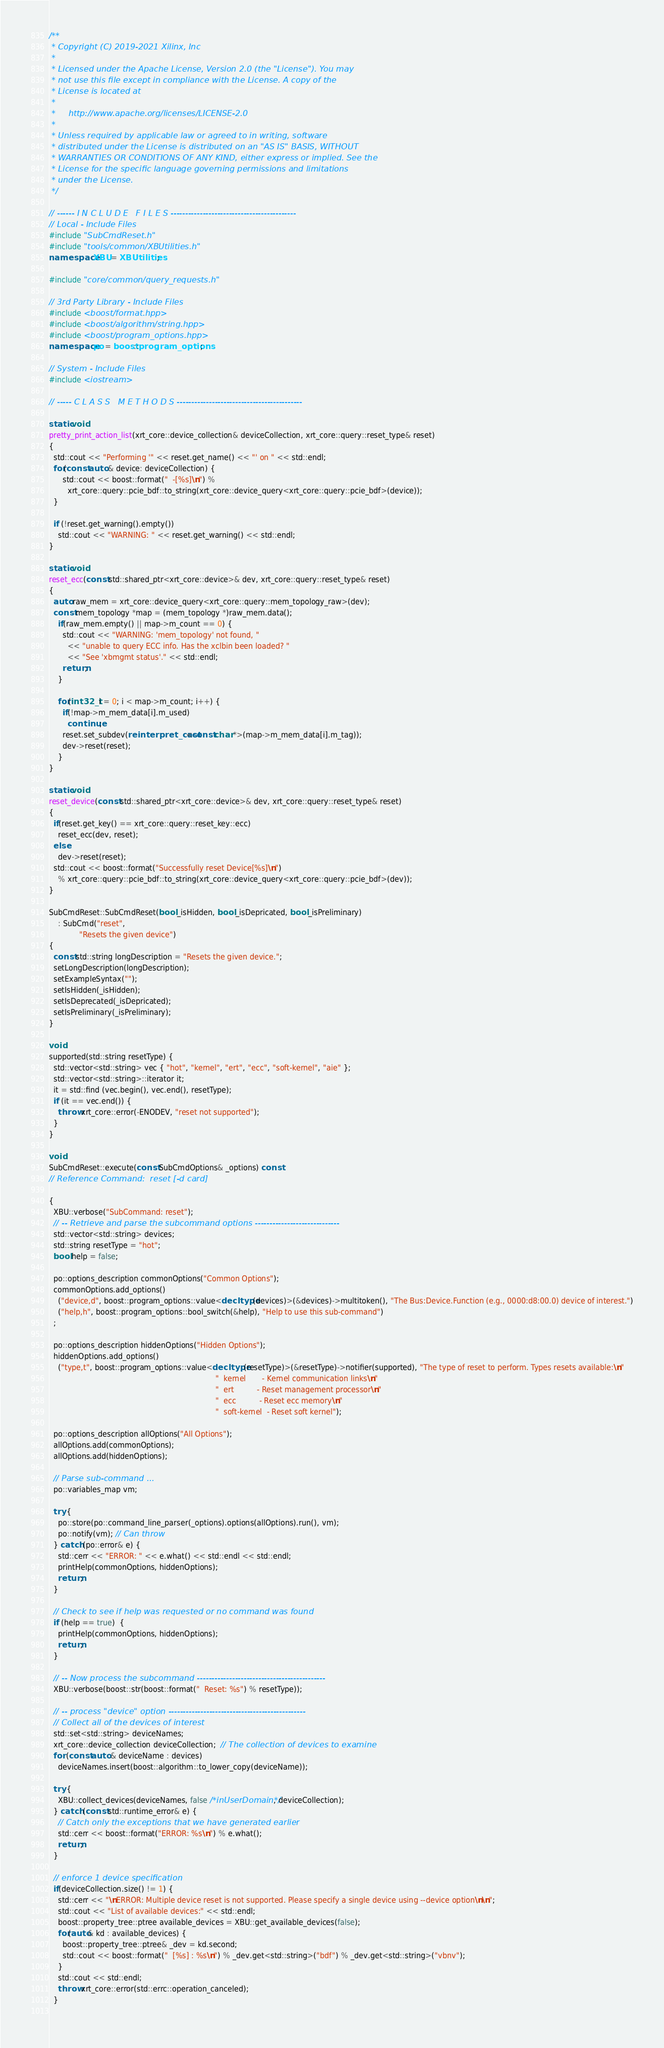Convert code to text. <code><loc_0><loc_0><loc_500><loc_500><_C++_>/**
 * Copyright (C) 2019-2021 Xilinx, Inc
 *
 * Licensed under the Apache License, Version 2.0 (the "License"). You may
 * not use this file except in compliance with the License. A copy of the
 * License is located at
 *
 *     http://www.apache.org/licenses/LICENSE-2.0
 *
 * Unless required by applicable law or agreed to in writing, software
 * distributed under the License is distributed on an "AS IS" BASIS, WITHOUT
 * WARRANTIES OR CONDITIONS OF ANY KIND, either express or implied. See the
 * License for the specific language governing permissions and limitations
 * under the License.
 */

// ------ I N C L U D E   F I L E S -------------------------------------------
// Local - Include Files
#include "SubCmdReset.h"
#include "tools/common/XBUtilities.h"
namespace XBU = XBUtilities;

#include "core/common/query_requests.h"

// 3rd Party Library - Include Files
#include <boost/format.hpp>
#include <boost/algorithm/string.hpp>
#include <boost/program_options.hpp>
namespace po = boost::program_options;

// System - Include Files
#include <iostream>

// ----- C L A S S   M E T H O D S -------------------------------------------

static void
pretty_print_action_list(xrt_core::device_collection& deviceCollection, xrt_core::query::reset_type& reset)
{
  std::cout << "Performing '" << reset.get_name() << "' on " << std::endl;
  for(const auto & device: deviceCollection) {
      std::cout << boost::format("  -[%s]\n") % 
        xrt_core::query::pcie_bdf::to_string(xrt_core::device_query<xrt_core::query::pcie_bdf>(device));
  }

  if (!reset.get_warning().empty())
    std::cout << "WARNING: " << reset.get_warning() << std::endl;
}

static void 
reset_ecc(const std::shared_ptr<xrt_core::device>& dev, xrt_core::query::reset_type& reset)
{
  auto raw_mem = xrt_core::device_query<xrt_core::query::mem_topology_raw>(dev);
  const mem_topology *map = (mem_topology *)raw_mem.data();
    if(raw_mem.empty() || map->m_count == 0) {
      std::cout << "WARNING: 'mem_topology' not found, "
        << "unable to query ECC info. Has the xclbin been loaded? "
        << "See 'xbmgmt status'." << std::endl;
      return;
    }

    for(int32_t i = 0; i < map->m_count; i++) {
      if(!map->m_mem_data[i].m_used)
        continue;
      reset.set_subdev(reinterpret_cast<const char *>(map->m_mem_data[i].m_tag));
      dev->reset(reset);
    }
}

static void
reset_device(const std::shared_ptr<xrt_core::device>& dev, xrt_core::query::reset_type& reset)
{  
  if(reset.get_key() == xrt_core::query::reset_key::ecc)
    reset_ecc(dev, reset);
  else
    dev->reset(reset);
  std::cout << boost::format("Successfully reset Device[%s]\n")
    % xrt_core::query::pcie_bdf::to_string(xrt_core::device_query<xrt_core::query::pcie_bdf>(dev));
}

SubCmdReset::SubCmdReset(bool _isHidden, bool _isDepricated, bool _isPreliminary)
    : SubCmd("reset", 
             "Resets the given device")
{
  const std::string longDescription = "Resets the given device.";
  setLongDescription(longDescription);
  setExampleSyntax("");
  setIsHidden(_isHidden);
  setIsDeprecated(_isDepricated);
  setIsPreliminary(_isPreliminary);
}

void
supported(std::string resetType) {
  std::vector<std::string> vec { "hot", "kernel", "ert", "ecc", "soft-kernel", "aie" };
  std::vector<std::string>::iterator it;
  it = std::find (vec.begin(), vec.end(), resetType);
  if (it == vec.end()) {
    throw xrt_core::error(-ENODEV, "reset not supported");
  }
}

void
SubCmdReset::execute(const SubCmdOptions& _options) const
// Reference Command:  reset [-d card]

{
  XBU::verbose("SubCommand: reset");
  // -- Retrieve and parse the subcommand options -----------------------------
  std::vector<std::string> devices;
  std::string resetType = "hot";
  bool help = false;

  po::options_description commonOptions("Common Options");
  commonOptions.add_options()
    ("device,d", boost::program_options::value<decltype(devices)>(&devices)->multitoken(), "The Bus:Device.Function (e.g., 0000:d8:00.0) device of interest.")
    ("help,h", boost::program_options::bool_switch(&help), "Help to use this sub-command")
  ;

  po::options_description hiddenOptions("Hidden Options");
  hiddenOptions.add_options()
    ("type,t", boost::program_options::value<decltype(resetType)>(&resetType)->notifier(supported), "The type of reset to perform. Types resets available:\n"
                                                                        "  kernel       - Kernel communication links\n" 
                                                                        "  ert          - Reset management processor\n"
                                                                        "  ecc          - Reset ecc memory\n"
                                                                        "  soft-kernel  - Reset soft kernel");

  po::options_description allOptions("All Options");
  allOptions.add(commonOptions);
  allOptions.add(hiddenOptions);

  // Parse sub-command ...
  po::variables_map vm;

  try {
    po::store(po::command_line_parser(_options).options(allOptions).run(), vm);
    po::notify(vm); // Can throw
  } catch (po::error& e) {
    std::cerr << "ERROR: " << e.what() << std::endl << std::endl;
    printHelp(commonOptions, hiddenOptions);
    return;
  }

  // Check to see if help was requested or no command was found
  if (help == true)  {
    printHelp(commonOptions, hiddenOptions);
    return;
  }

  // -- Now process the subcommand --------------------------------------------
  XBU::verbose(boost::str(boost::format("  Reset: %s") % resetType));

  // -- process "device" option -----------------------------------------------
  // Collect all of the devices of interest
  std::set<std::string> deviceNames;
  xrt_core::device_collection deviceCollection;  // The collection of devices to examine
  for (const auto & deviceName : devices) 
    deviceNames.insert(boost::algorithm::to_lower_copy(deviceName));

  try {
    XBU::collect_devices(deviceNames, false /*inUserDomain*/, deviceCollection);
  } catch (const std::runtime_error& e) {
    // Catch only the exceptions that we have generated earlier
    std::cerr << boost::format("ERROR: %s\n") % e.what();
    return;
  }

  // enforce 1 device specification
  if(deviceCollection.size() != 1) {
    std::cerr << "\nERROR: Multiple device reset is not supported. Please specify a single device using --device option\n\n";
    std::cout << "List of available devices:" << std::endl;
    boost::property_tree::ptree available_devices = XBU::get_available_devices(false);
    for(auto& kd : available_devices) {
      boost::property_tree::ptree& _dev = kd.second;
      std::cout << boost::format("  [%s] : %s\n") % _dev.get<std::string>("bdf") % _dev.get<std::string>("vbnv");
    }
    std::cout << std::endl;
    throw xrt_core::error(std::errc::operation_canceled);
  }
  </code> 